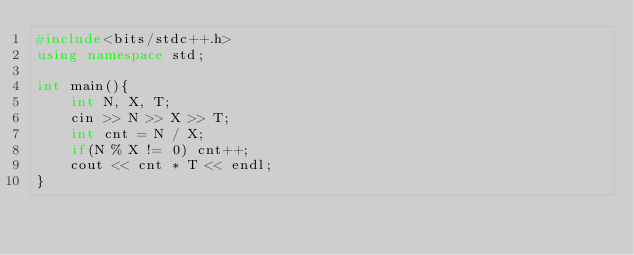Convert code to text. <code><loc_0><loc_0><loc_500><loc_500><_C++_>#include<bits/stdc++.h>
using namespace std;

int main(){
    int N, X, T;
    cin >> N >> X >> T;
    int cnt = N / X;
    if(N % X != 0) cnt++;
    cout << cnt * T << endl; 
}</code> 